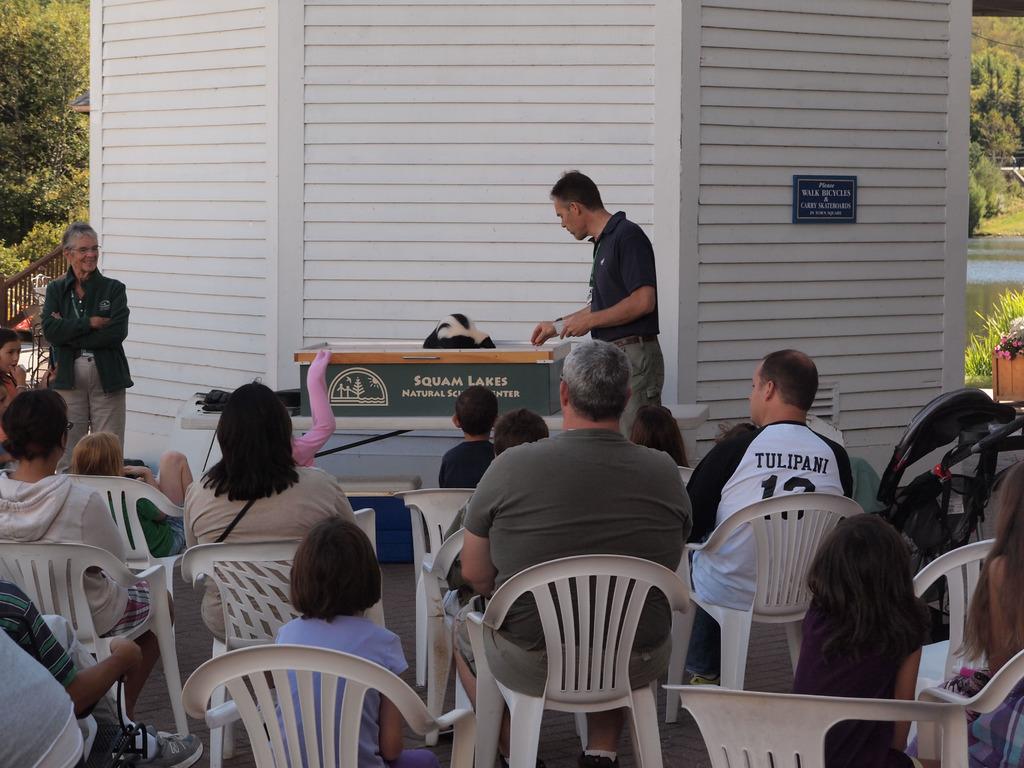What is name printed in the white tshirt?
Give a very brief answer. Tulipani. 